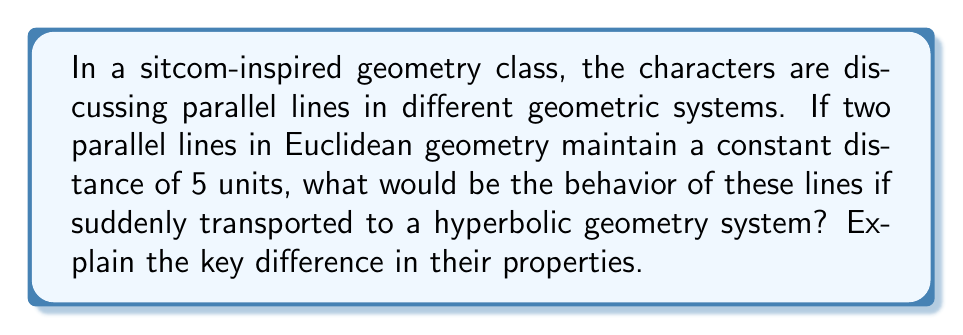Show me your answer to this math problem. Let's break this down step-by-step:

1) In Euclidean geometry:
   - Parallel lines maintain a constant distance from each other.
   - In this case, the distance is 5 units.
   - We can represent this with two straight lines:

   [asy]
   import geometry;
   
   size(200);
   
   draw((0,0)--(100,0));
   draw((0,5)--(100,5));
   
   label("5 units", (50,2.5), E);
   [/asy]

2) In hyperbolic geometry:
   - The concept of parallel lines is different.
   - Two lines are considered parallel if they do not intersect.
   - However, parallel lines in hyperbolic geometry do not maintain a constant distance.

3) Key difference:
   - In hyperbolic geometry, parallel lines "curve away" from each other.
   - The distance between them increases as you move along the lines.
   - This can be visualized in the Poincaré disk model:

   [asy]
   import geometry;
   
   size(200);
   
   path c = circle((0,0),1);
   draw(c);
   
   path l1 = (0.5,-1)..(0,0)..(0.5,1);
   path l2 = (1,-1)..(0.6,0)..(1,1);
   
   draw(l1, blue);
   draw(l2, blue);
   
   label("Increasing distance", (0.75,0), E);
   [/asy]

4) In our sitcom-inspired scenario:
   - If the lines were suddenly transported to a hyperbolic system, they would no longer remain 5 units apart.
   - They would start to curve away from each other, with the distance between them continuously increasing.

5) This property is due to the negative curvature of hyperbolic space, which contrasts with the flat nature of Euclidean space.
Answer: In hyperbolic geometry, the parallel lines would curve away from each other, with their distance continuously increasing, unlike in Euclidean geometry where they remain 5 units apart. 